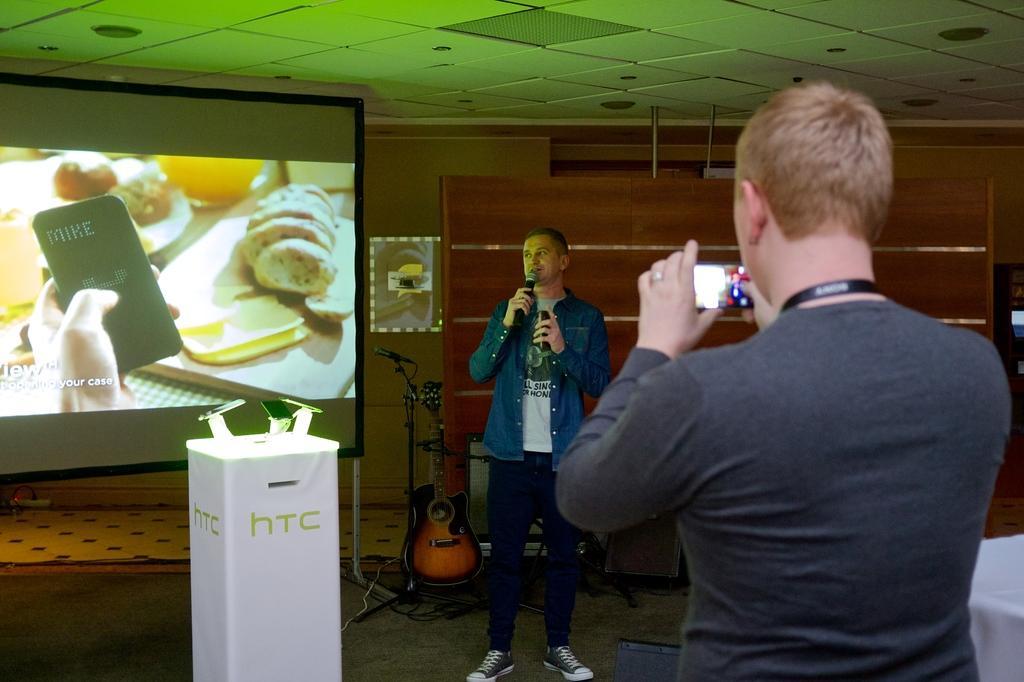Could you give a brief overview of what you see in this image? In this image in front there is a person holding the mobile. In front of him there is another person holding the mike and some object. Behind him there is a guitar. There is a mike. There is a wooden board. There is a wall with the photo frame on it. At the bottom of the image there is a mat. There is a table and on top of the table there are mobiles. In the background of the image there is a screen. On top of the image there are lights. 